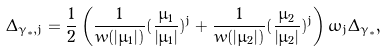<formula> <loc_0><loc_0><loc_500><loc_500>\Delta _ { { \gamma _ { * } } , j } = \frac { 1 } { 2 } \left ( \frac { 1 } { { w ( \left | { \mu _ { 1 } } \right | ) } } ( \frac { \bar { \mu } _ { 1 } } { { \left | { \mu _ { 1 } } \right | } } ) ^ { j } + \frac { 1 } { { w ( \left | { \mu _ { 2 } } \right | ) } } ( \frac { \bar { \mu } _ { 2 } } { { \left | { \mu _ { 2 } } \right | } } ) ^ { j } \right ) \omega _ { j } \Delta _ { \gamma _ { * } } ,</formula> 